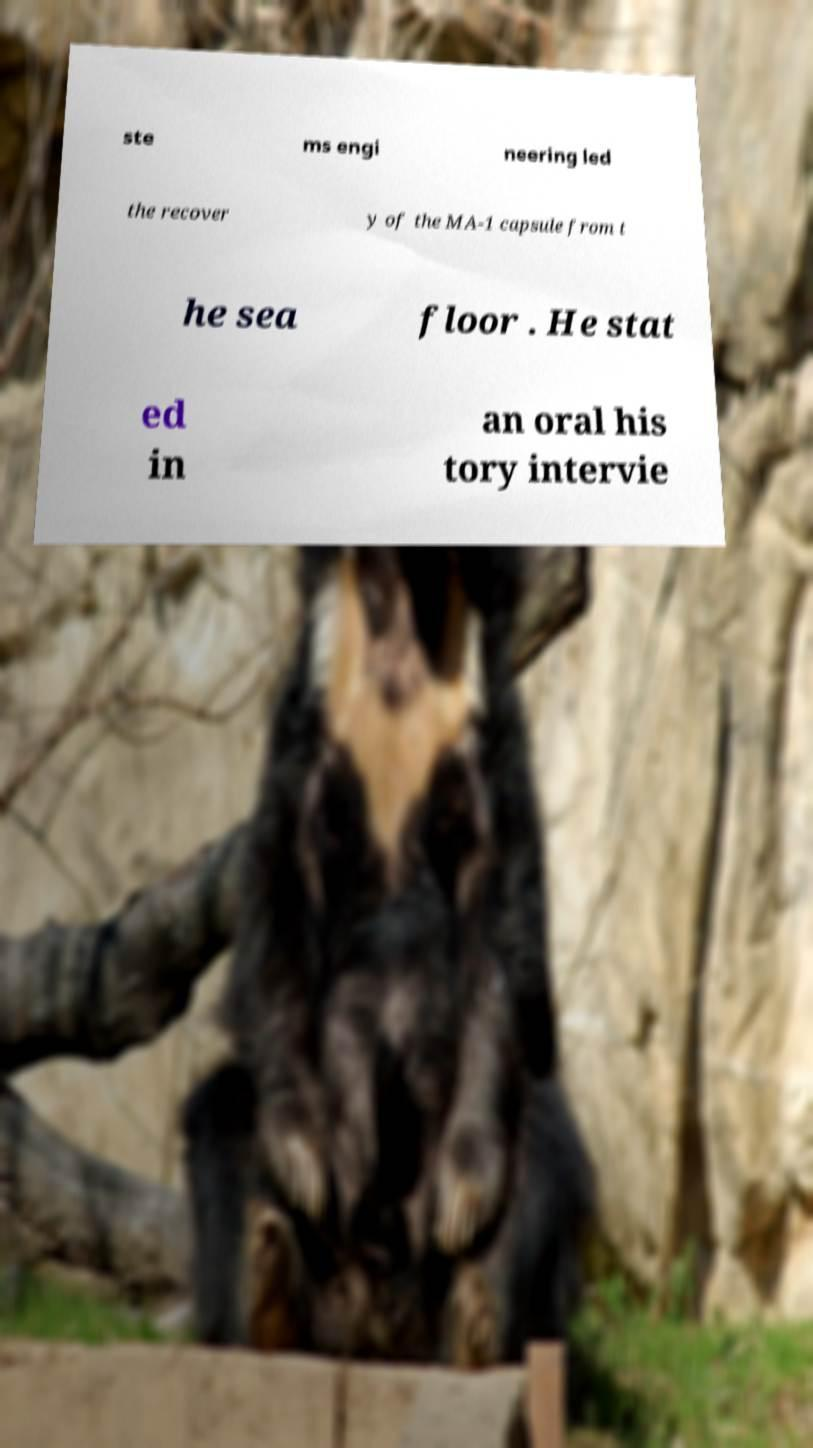There's text embedded in this image that I need extracted. Can you transcribe it verbatim? ste ms engi neering led the recover y of the MA-1 capsule from t he sea floor . He stat ed in an oral his tory intervie 